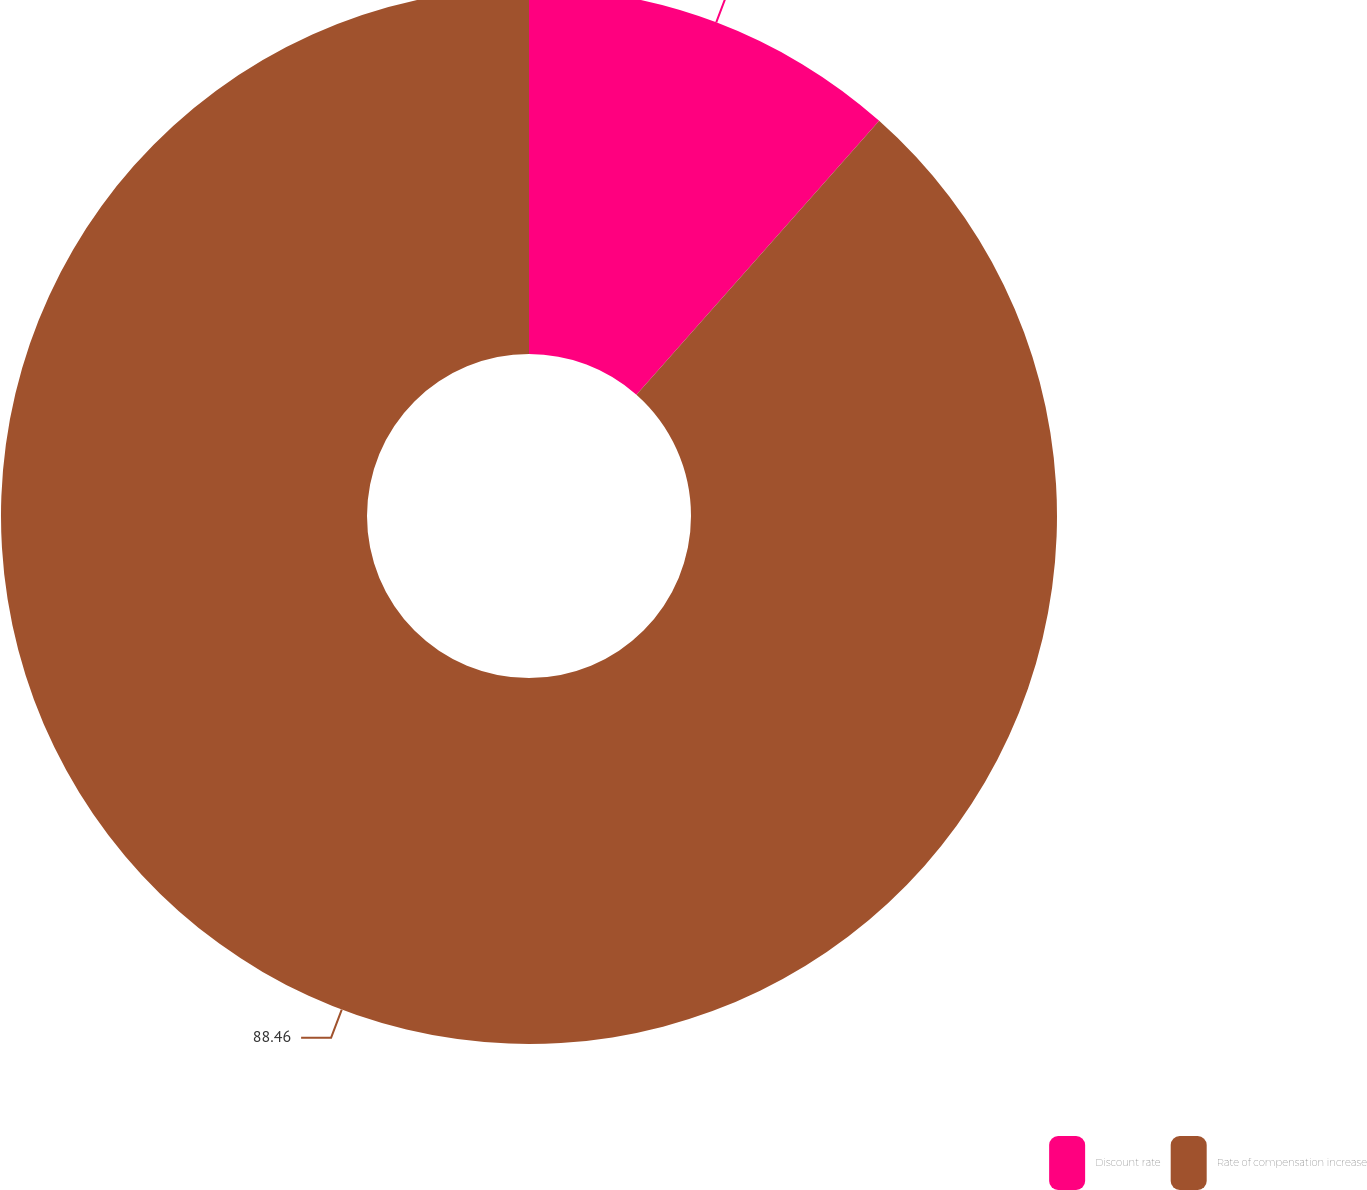<chart> <loc_0><loc_0><loc_500><loc_500><pie_chart><fcel>Discount rate<fcel>Rate of compensation increase<nl><fcel>11.54%<fcel>88.46%<nl></chart> 